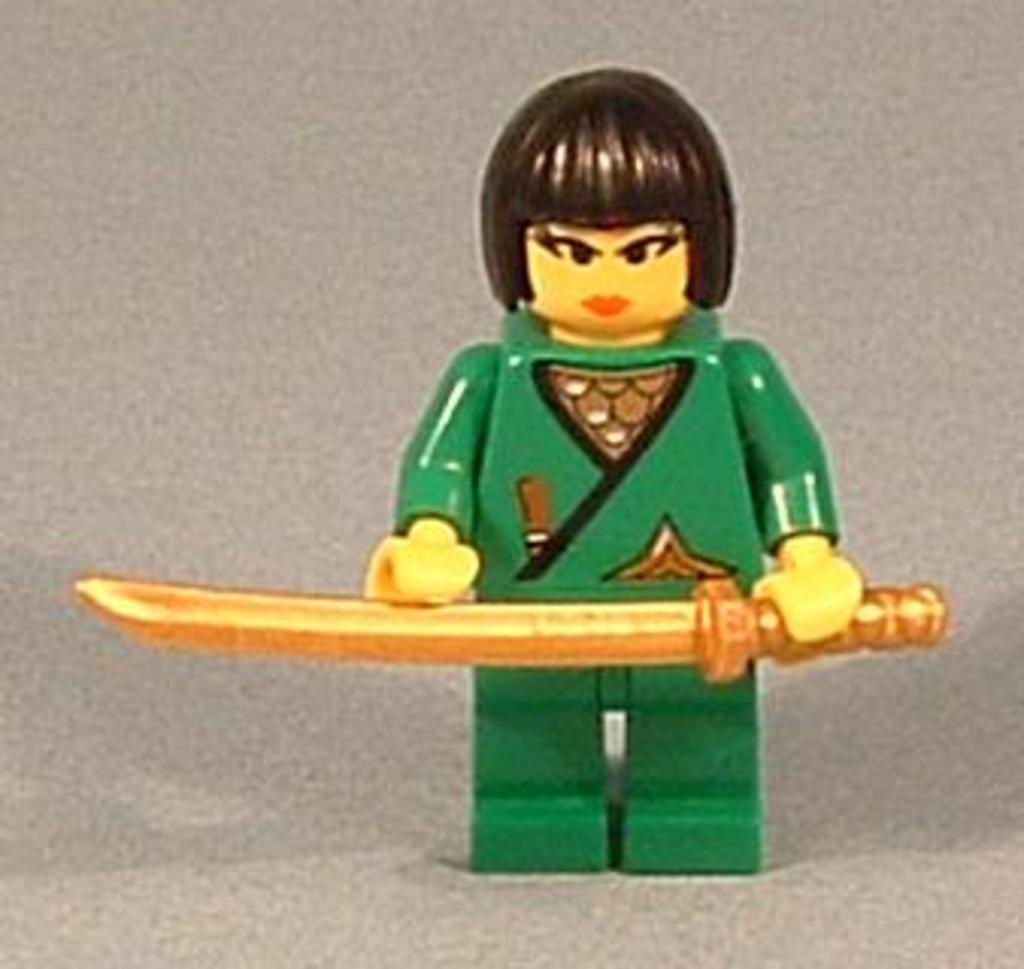What type of image is being described? The image is animated. Who is the main character in the image? There is a girl in the image. What is the girl holding in the image? The girl is holding a knife. What is the girl wearing in the image? The girl is wearing a green dress. Can you see any butter on the girl's green dress in the image? There is no butter present in the image. 